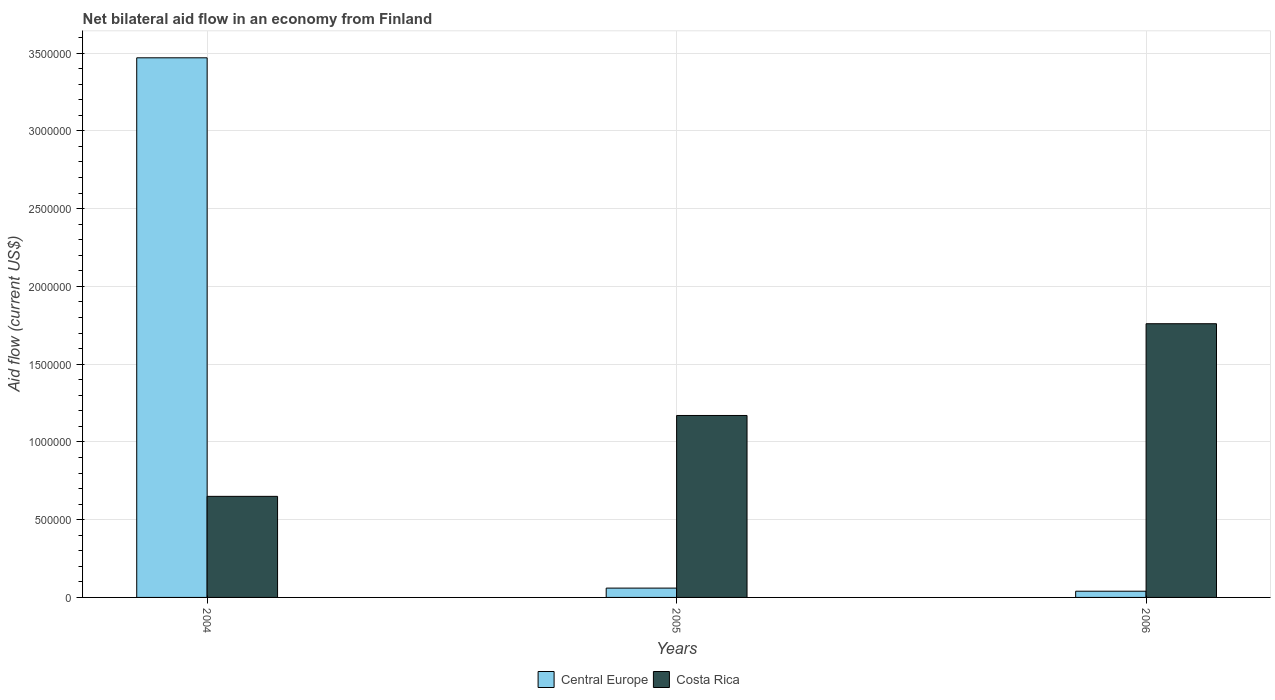How many different coloured bars are there?
Make the answer very short. 2. What is the label of the 2nd group of bars from the left?
Provide a succinct answer. 2005. In how many cases, is the number of bars for a given year not equal to the number of legend labels?
Your answer should be very brief. 0. What is the net bilateral aid flow in Costa Rica in 2005?
Your answer should be compact. 1.17e+06. Across all years, what is the maximum net bilateral aid flow in Costa Rica?
Your answer should be very brief. 1.76e+06. Across all years, what is the minimum net bilateral aid flow in Costa Rica?
Your answer should be compact. 6.50e+05. In which year was the net bilateral aid flow in Costa Rica maximum?
Give a very brief answer. 2006. What is the total net bilateral aid flow in Central Europe in the graph?
Your answer should be compact. 3.57e+06. What is the difference between the net bilateral aid flow in Central Europe in 2004 and that in 2006?
Make the answer very short. 3.43e+06. What is the difference between the net bilateral aid flow in Central Europe in 2006 and the net bilateral aid flow in Costa Rica in 2004?
Provide a succinct answer. -6.10e+05. What is the average net bilateral aid flow in Central Europe per year?
Provide a short and direct response. 1.19e+06. In the year 2006, what is the difference between the net bilateral aid flow in Central Europe and net bilateral aid flow in Costa Rica?
Keep it short and to the point. -1.72e+06. In how many years, is the net bilateral aid flow in Costa Rica greater than 1800000 US$?
Your answer should be very brief. 0. What is the ratio of the net bilateral aid flow in Costa Rica in 2004 to that in 2006?
Provide a succinct answer. 0.37. Is the difference between the net bilateral aid flow in Central Europe in 2004 and 2006 greater than the difference between the net bilateral aid flow in Costa Rica in 2004 and 2006?
Your response must be concise. Yes. What is the difference between the highest and the second highest net bilateral aid flow in Costa Rica?
Make the answer very short. 5.90e+05. What is the difference between the highest and the lowest net bilateral aid flow in Central Europe?
Your response must be concise. 3.43e+06. Is the sum of the net bilateral aid flow in Central Europe in 2004 and 2005 greater than the maximum net bilateral aid flow in Costa Rica across all years?
Offer a very short reply. Yes. What does the 1st bar from the left in 2006 represents?
Offer a very short reply. Central Europe. What does the 2nd bar from the right in 2006 represents?
Provide a succinct answer. Central Europe. Are all the bars in the graph horizontal?
Provide a succinct answer. No. What is the difference between two consecutive major ticks on the Y-axis?
Offer a terse response. 5.00e+05. How are the legend labels stacked?
Provide a succinct answer. Horizontal. What is the title of the graph?
Provide a succinct answer. Net bilateral aid flow in an economy from Finland. Does "Uzbekistan" appear as one of the legend labels in the graph?
Provide a succinct answer. No. What is the Aid flow (current US$) in Central Europe in 2004?
Provide a short and direct response. 3.47e+06. What is the Aid flow (current US$) in Costa Rica in 2004?
Ensure brevity in your answer.  6.50e+05. What is the Aid flow (current US$) in Central Europe in 2005?
Make the answer very short. 6.00e+04. What is the Aid flow (current US$) of Costa Rica in 2005?
Your answer should be compact. 1.17e+06. What is the Aid flow (current US$) of Costa Rica in 2006?
Your response must be concise. 1.76e+06. Across all years, what is the maximum Aid flow (current US$) in Central Europe?
Ensure brevity in your answer.  3.47e+06. Across all years, what is the maximum Aid flow (current US$) of Costa Rica?
Make the answer very short. 1.76e+06. Across all years, what is the minimum Aid flow (current US$) of Central Europe?
Offer a terse response. 4.00e+04. Across all years, what is the minimum Aid flow (current US$) of Costa Rica?
Provide a succinct answer. 6.50e+05. What is the total Aid flow (current US$) in Central Europe in the graph?
Make the answer very short. 3.57e+06. What is the total Aid flow (current US$) in Costa Rica in the graph?
Keep it short and to the point. 3.58e+06. What is the difference between the Aid flow (current US$) of Central Europe in 2004 and that in 2005?
Make the answer very short. 3.41e+06. What is the difference between the Aid flow (current US$) in Costa Rica in 2004 and that in 2005?
Keep it short and to the point. -5.20e+05. What is the difference between the Aid flow (current US$) of Central Europe in 2004 and that in 2006?
Provide a short and direct response. 3.43e+06. What is the difference between the Aid flow (current US$) in Costa Rica in 2004 and that in 2006?
Make the answer very short. -1.11e+06. What is the difference between the Aid flow (current US$) of Central Europe in 2005 and that in 2006?
Provide a succinct answer. 2.00e+04. What is the difference between the Aid flow (current US$) of Costa Rica in 2005 and that in 2006?
Offer a terse response. -5.90e+05. What is the difference between the Aid flow (current US$) in Central Europe in 2004 and the Aid flow (current US$) in Costa Rica in 2005?
Offer a terse response. 2.30e+06. What is the difference between the Aid flow (current US$) in Central Europe in 2004 and the Aid flow (current US$) in Costa Rica in 2006?
Provide a short and direct response. 1.71e+06. What is the difference between the Aid flow (current US$) of Central Europe in 2005 and the Aid flow (current US$) of Costa Rica in 2006?
Provide a succinct answer. -1.70e+06. What is the average Aid flow (current US$) in Central Europe per year?
Provide a short and direct response. 1.19e+06. What is the average Aid flow (current US$) of Costa Rica per year?
Offer a terse response. 1.19e+06. In the year 2004, what is the difference between the Aid flow (current US$) in Central Europe and Aid flow (current US$) in Costa Rica?
Give a very brief answer. 2.82e+06. In the year 2005, what is the difference between the Aid flow (current US$) in Central Europe and Aid flow (current US$) in Costa Rica?
Your answer should be very brief. -1.11e+06. In the year 2006, what is the difference between the Aid flow (current US$) in Central Europe and Aid flow (current US$) in Costa Rica?
Offer a very short reply. -1.72e+06. What is the ratio of the Aid flow (current US$) of Central Europe in 2004 to that in 2005?
Ensure brevity in your answer.  57.83. What is the ratio of the Aid flow (current US$) in Costa Rica in 2004 to that in 2005?
Give a very brief answer. 0.56. What is the ratio of the Aid flow (current US$) of Central Europe in 2004 to that in 2006?
Your answer should be compact. 86.75. What is the ratio of the Aid flow (current US$) in Costa Rica in 2004 to that in 2006?
Provide a succinct answer. 0.37. What is the ratio of the Aid flow (current US$) of Costa Rica in 2005 to that in 2006?
Give a very brief answer. 0.66. What is the difference between the highest and the second highest Aid flow (current US$) in Central Europe?
Offer a very short reply. 3.41e+06. What is the difference between the highest and the second highest Aid flow (current US$) of Costa Rica?
Keep it short and to the point. 5.90e+05. What is the difference between the highest and the lowest Aid flow (current US$) in Central Europe?
Ensure brevity in your answer.  3.43e+06. What is the difference between the highest and the lowest Aid flow (current US$) in Costa Rica?
Your response must be concise. 1.11e+06. 